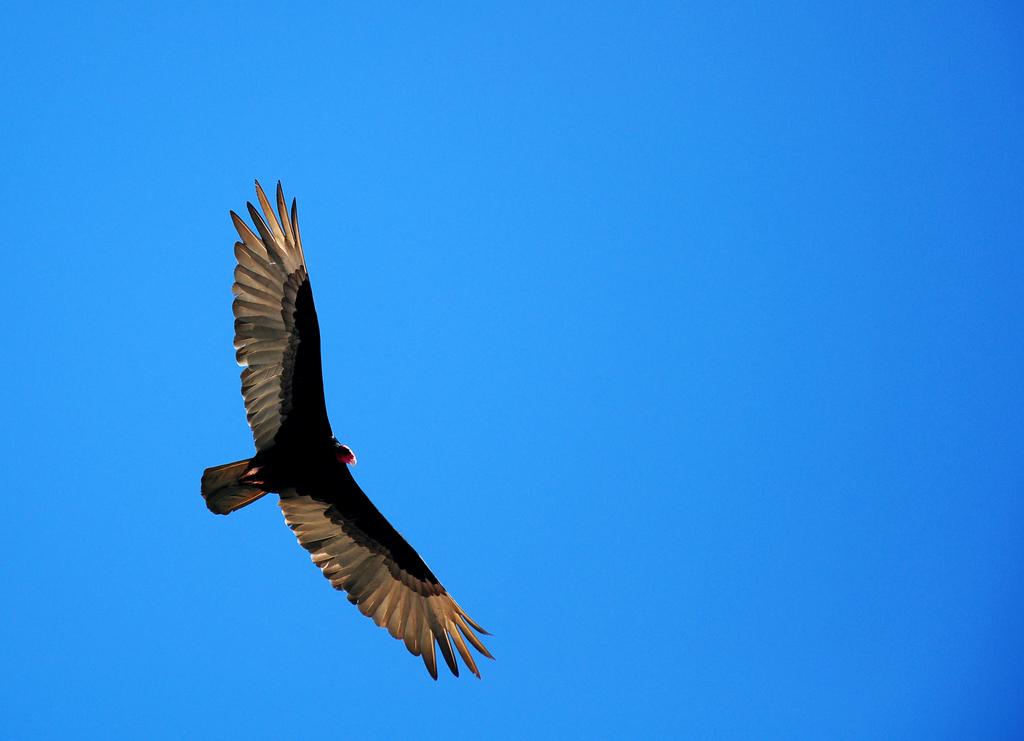What type of animal is present in the image? There is a bird in the image. What is the bird doing in the image? The bird is flying. What can be seen in the background of the image? The sky is visible behind the bird. What type of kettle is being used by the bird in the image? There is no kettle present in the image; it features a bird flying in the sky. Is the bird playing baseball in the image? There is no indication of a baseball or any baseball-related activity in the image. 